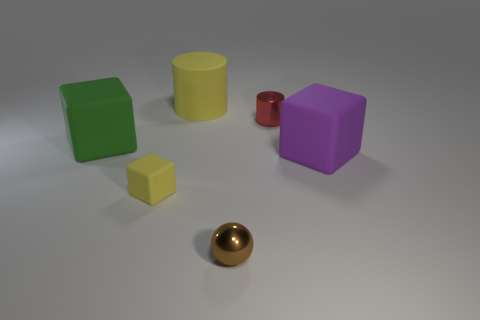Is the shape of the large object that is to the left of the yellow cube the same as the purple matte object to the right of the tiny yellow rubber block?
Keep it short and to the point. Yes. How many things are either tiny metal things right of the tiny brown sphere or big blue metallic cubes?
Ensure brevity in your answer.  1. There is a object that is the same color as the big cylinder; what is its material?
Provide a short and direct response. Rubber. Are there any spheres that are behind the large green matte object left of the yellow thing to the left of the yellow matte cylinder?
Ensure brevity in your answer.  No. Is the number of tiny yellow matte cubes that are on the left side of the big green object less than the number of green matte blocks that are right of the red shiny object?
Your answer should be very brief. No. What is the color of the thing that is made of the same material as the tiny red cylinder?
Your answer should be compact. Brown. There is a small metal object behind the tiny object left of the tiny brown metal object; what color is it?
Keep it short and to the point. Red. Is there a big matte thing that has the same color as the tiny shiny sphere?
Provide a succinct answer. No. There is a brown object that is the same size as the red shiny thing; what shape is it?
Provide a short and direct response. Sphere. There is a big object to the left of the yellow block; how many red metal objects are in front of it?
Your response must be concise. 0. 